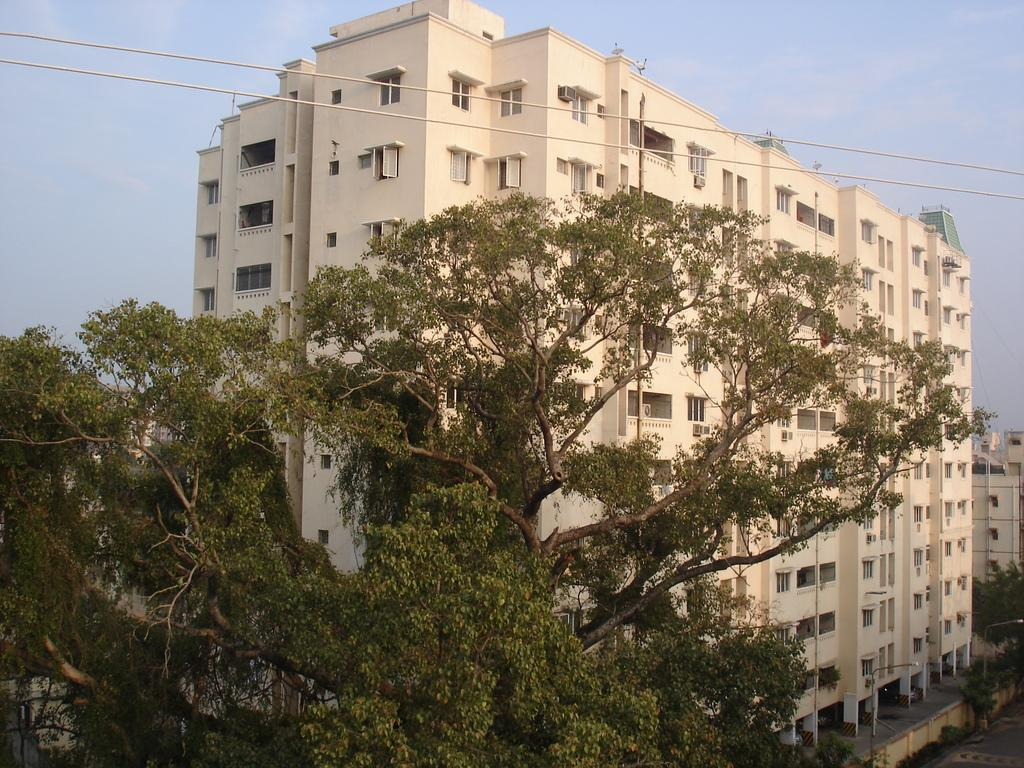What type of structures can be seen in the image? There are buildings in the image. What other natural elements are present in the image? There are trees in the image. What can be seen at the top of the image? Wires and the sky are visible at the top of the image. What else is present in the image besides buildings and trees? There are poles in the image. How many pigs are visible in the image? There are no pigs present in the image. What type of airplane can be seen flying over the buildings in the image? There is no airplane visible in the image; only buildings, trees, wires, the sky, and poles are present. 